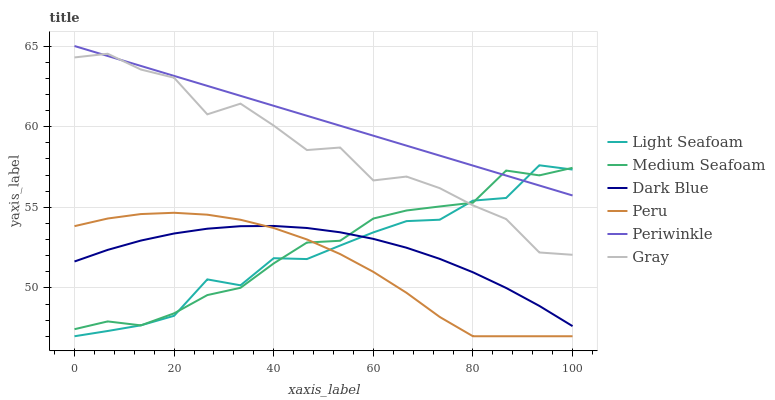Does Peru have the minimum area under the curve?
Answer yes or no. Yes. Does Periwinkle have the maximum area under the curve?
Answer yes or no. Yes. Does Dark Blue have the minimum area under the curve?
Answer yes or no. No. Does Dark Blue have the maximum area under the curve?
Answer yes or no. No. Is Periwinkle the smoothest?
Answer yes or no. Yes. Is Gray the roughest?
Answer yes or no. Yes. Is Dark Blue the smoothest?
Answer yes or no. No. Is Dark Blue the roughest?
Answer yes or no. No. Does Peru have the lowest value?
Answer yes or no. Yes. Does Dark Blue have the lowest value?
Answer yes or no. No. Does Periwinkle have the highest value?
Answer yes or no. Yes. Does Dark Blue have the highest value?
Answer yes or no. No. Is Dark Blue less than Gray?
Answer yes or no. Yes. Is Gray greater than Peru?
Answer yes or no. Yes. Does Dark Blue intersect Light Seafoam?
Answer yes or no. Yes. Is Dark Blue less than Light Seafoam?
Answer yes or no. No. Is Dark Blue greater than Light Seafoam?
Answer yes or no. No. Does Dark Blue intersect Gray?
Answer yes or no. No. 